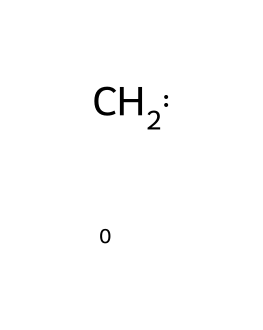What is the molecular formula of singlet methylene? The SMILES representation shows two hydrogen atoms bonded to a carbon atom. Thus, the molecular formula can be derived as CH2.
Answer: CH2 How many total atoms are present in singlet methylene? The SMILES indicates one carbon atom and two hydrogen atoms, totaling three atoms.
Answer: 3 What type of hybridization does the carbon in singlet methylene exhibit? The carbon atom in singlet methylene is sp² hybridized due to the formation of two sigma bonds with the hydrogen atoms and one lone pair.
Answer: sp² What is the bond angle around the carbon atom in singlet methylene? In an sp² hybridized system, the standard bond angle is 120 degrees as it forms a trigonal planar configuration.
Answer: 120 degrees What unique property do carbenes like singlet methylene have due to their structure? The presence of a lone pair on the carbon atom leads to high reactivity and can facilitate certain reactions like insertion or addition.
Answer: high reactivity Is singlet methylene stable or unstable in nature? Singlet methylene is known to be a transient species with a relatively short lifetime, thus indicating its instability.
Answer: unstable 